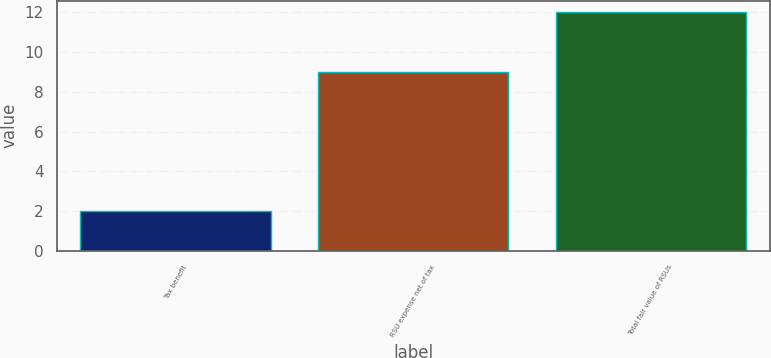Convert chart to OTSL. <chart><loc_0><loc_0><loc_500><loc_500><bar_chart><fcel>Tax benefit<fcel>RSU expense net of tax<fcel>Total fair value of RSUs<nl><fcel>2<fcel>9<fcel>12<nl></chart> 